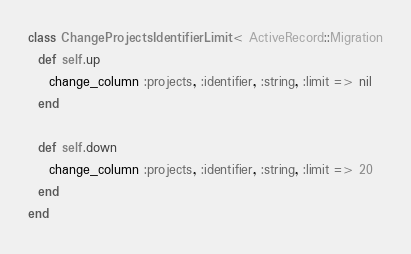Convert code to text. <code><loc_0><loc_0><loc_500><loc_500><_Ruby_>class ChangeProjectsIdentifierLimit < ActiveRecord::Migration
  def self.up
    change_column :projects, :identifier, :string, :limit => nil
  end

  def self.down
    change_column :projects, :identifier, :string, :limit => 20
  end
end
</code> 